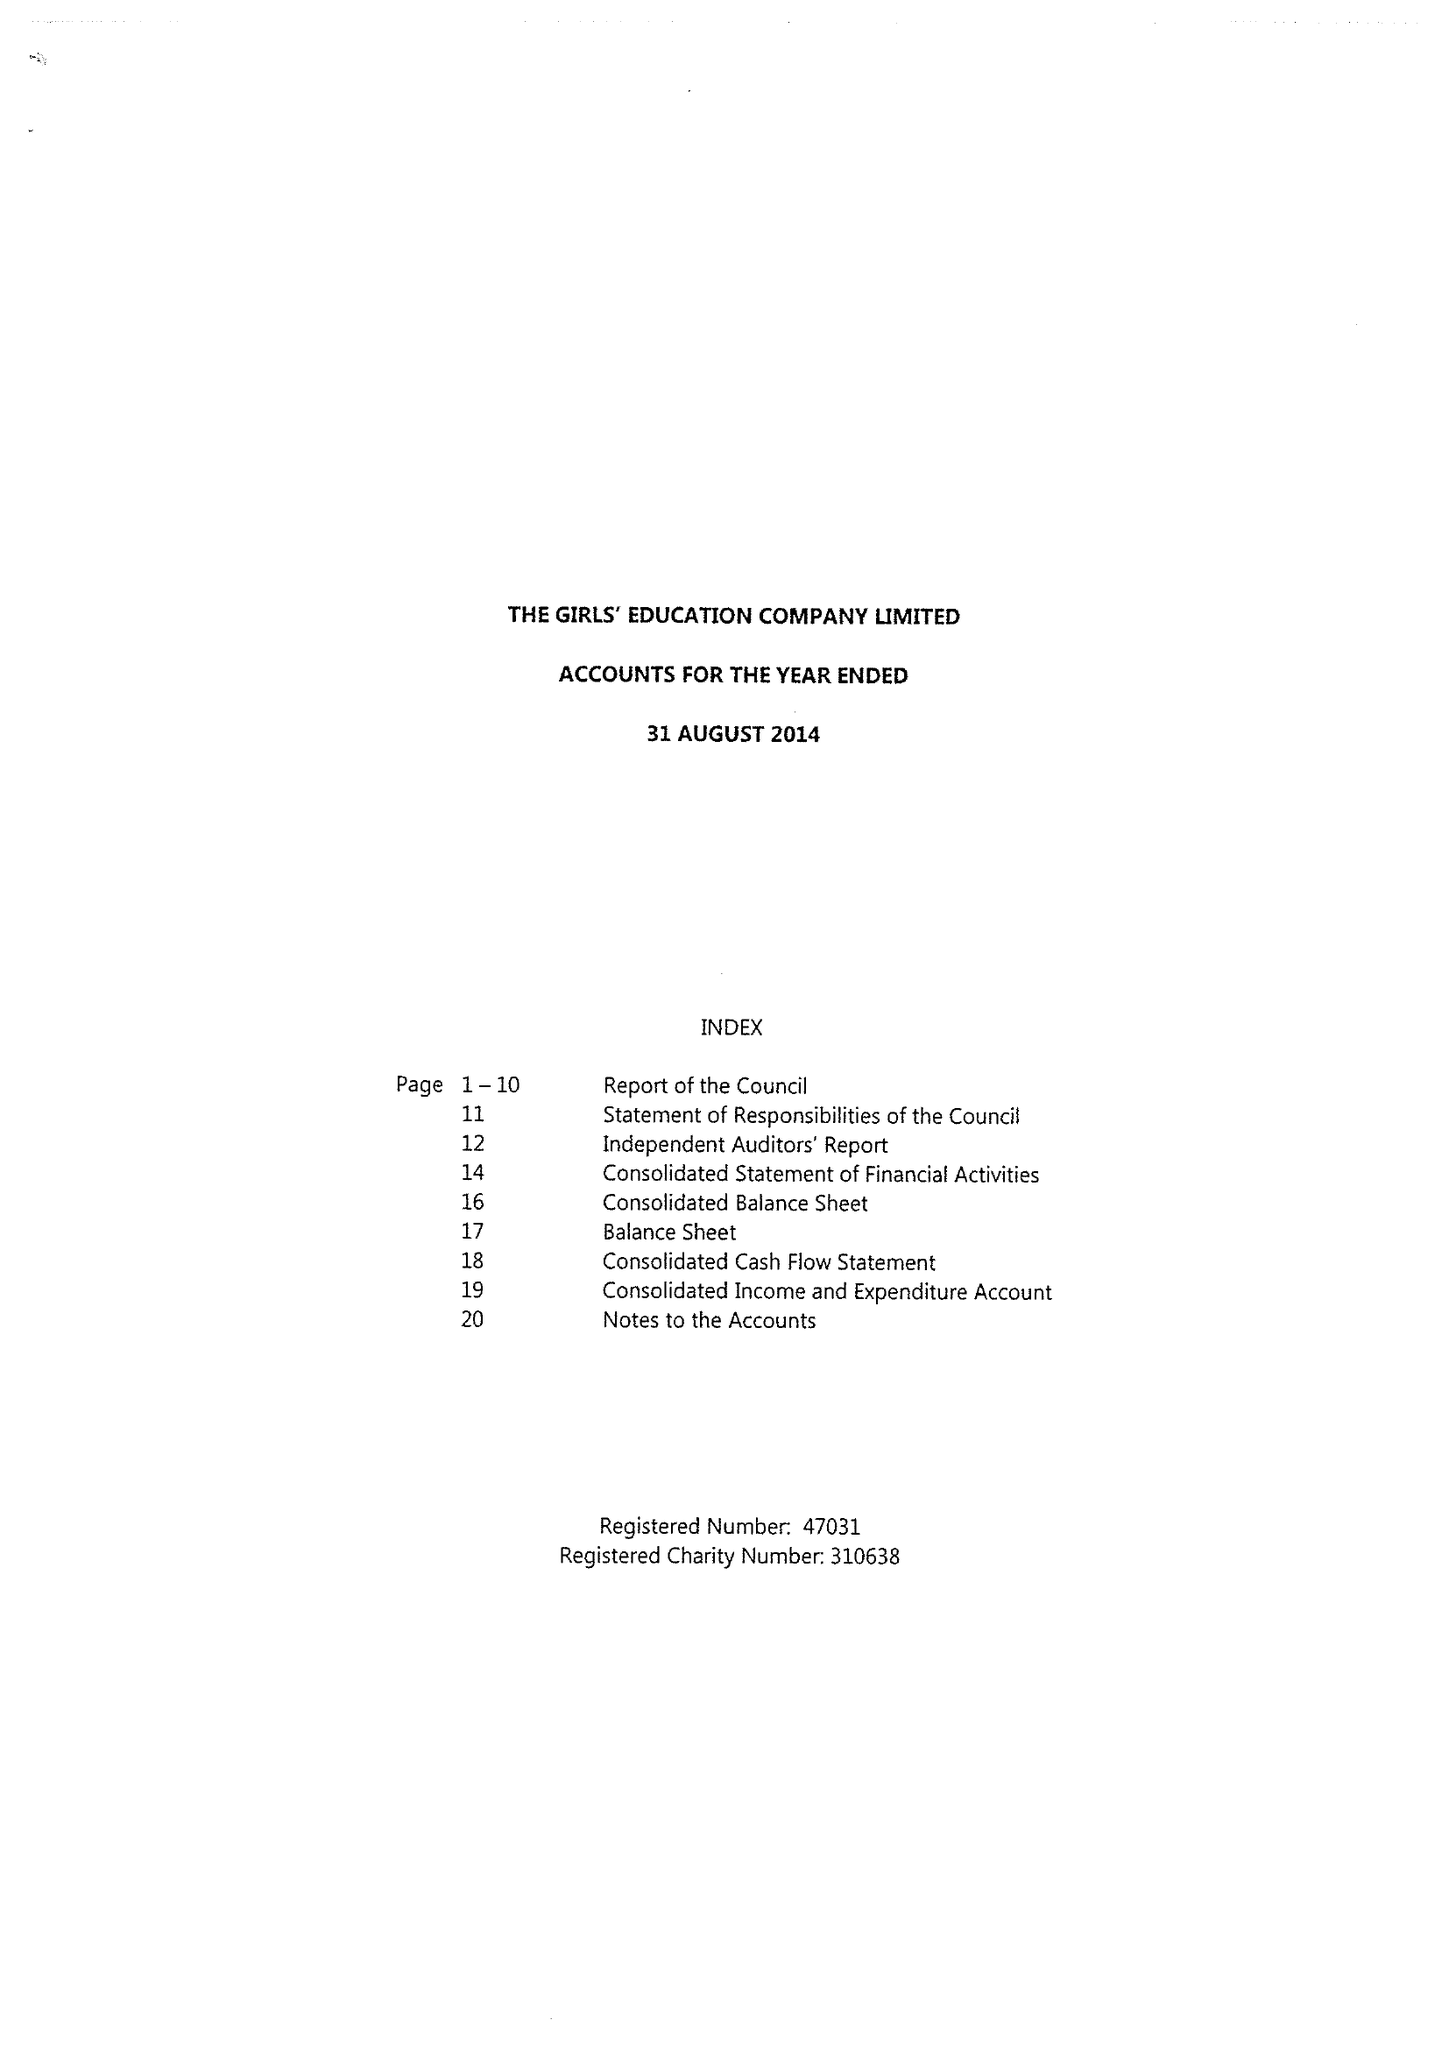What is the value for the charity_name?
Answer the question using a single word or phrase. Girls' Education Company Ltd. 